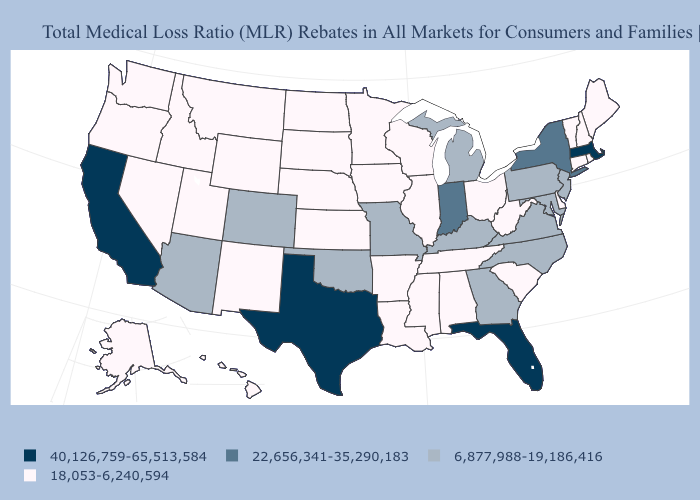What is the value of Maine?
Quick response, please. 18,053-6,240,594. Does Maryland have the lowest value in the USA?
Quick response, please. No. What is the value of Kentucky?
Write a very short answer. 6,877,988-19,186,416. Name the states that have a value in the range 6,877,988-19,186,416?
Short answer required. Arizona, Colorado, Georgia, Kentucky, Maryland, Michigan, Missouri, New Jersey, North Carolina, Oklahoma, Pennsylvania, Virginia. What is the value of Wisconsin?
Give a very brief answer. 18,053-6,240,594. Does Connecticut have the same value as Virginia?
Keep it brief. No. Does the map have missing data?
Answer briefly. No. Is the legend a continuous bar?
Give a very brief answer. No. Is the legend a continuous bar?
Write a very short answer. No. Does Ohio have the highest value in the MidWest?
Keep it brief. No. Does Nebraska have the highest value in the USA?
Write a very short answer. No. What is the highest value in states that border Georgia?
Be succinct. 40,126,759-65,513,584. What is the highest value in the South ?
Write a very short answer. 40,126,759-65,513,584. Among the states that border Texas , which have the lowest value?
Short answer required. Arkansas, Louisiana, New Mexico. Among the states that border Wyoming , does Utah have the highest value?
Keep it brief. No. 